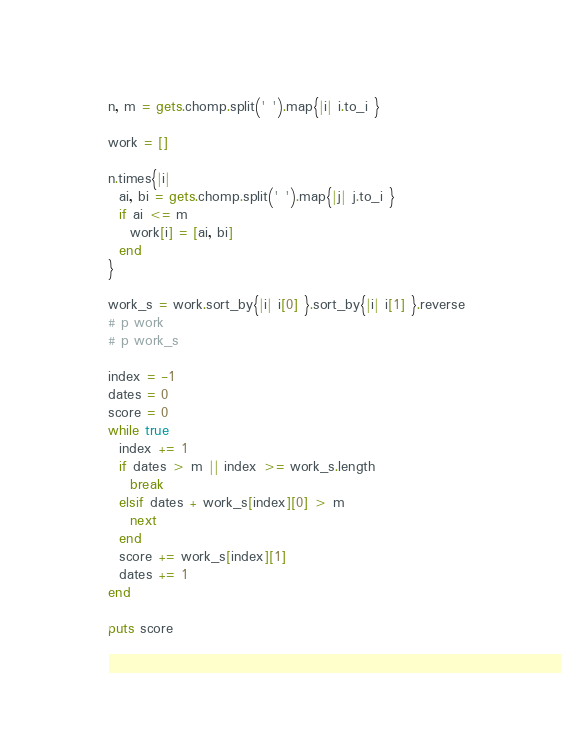<code> <loc_0><loc_0><loc_500><loc_500><_Ruby_>n, m = gets.chomp.split(' ').map{|i| i.to_i }

work = []

n.times{|i|
  ai, bi = gets.chomp.split(' ').map{|j| j.to_i }
  if ai <= m
    work[i] = [ai, bi]
  end
}

work_s = work.sort_by{|i| i[0] }.sort_by{|i| i[1] }.reverse
# p work
# p work_s

index = -1
dates = 0
score = 0
while true
  index += 1
  if dates > m || index >= work_s.length
    break
  elsif dates + work_s[index][0] > m
    next
  end
  score += work_s[index][1]
  dates += 1
end

puts score
</code> 